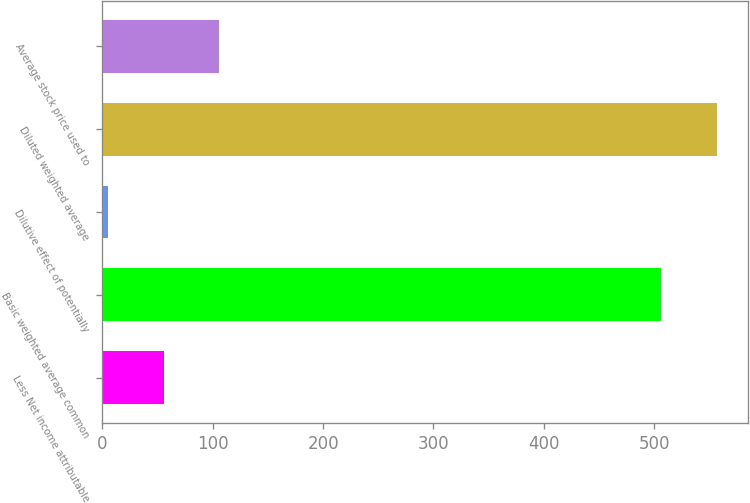<chart> <loc_0><loc_0><loc_500><loc_500><bar_chart><fcel>Less Net income attributable<fcel>Basic weighted average common<fcel>Dilutive effect of potentially<fcel>Diluted weighted average<fcel>Average stock price used to<nl><fcel>55.6<fcel>506<fcel>5<fcel>556.6<fcel>106.2<nl></chart> 